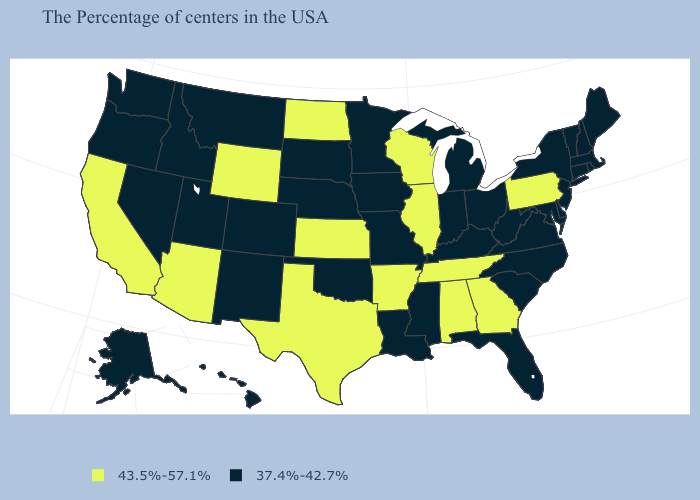Among the states that border West Virginia , does Maryland have the lowest value?
Keep it brief. Yes. Among the states that border Kentucky , does Illinois have the lowest value?
Concise answer only. No. Does the first symbol in the legend represent the smallest category?
Quick response, please. No. Which states have the lowest value in the South?
Keep it brief. Delaware, Maryland, Virginia, North Carolina, South Carolina, West Virginia, Florida, Kentucky, Mississippi, Louisiana, Oklahoma. Which states have the lowest value in the USA?
Be succinct. Maine, Massachusetts, Rhode Island, New Hampshire, Vermont, Connecticut, New York, New Jersey, Delaware, Maryland, Virginia, North Carolina, South Carolina, West Virginia, Ohio, Florida, Michigan, Kentucky, Indiana, Mississippi, Louisiana, Missouri, Minnesota, Iowa, Nebraska, Oklahoma, South Dakota, Colorado, New Mexico, Utah, Montana, Idaho, Nevada, Washington, Oregon, Alaska, Hawaii. Among the states that border Nevada , does Oregon have the highest value?
Short answer required. No. Name the states that have a value in the range 43.5%-57.1%?
Give a very brief answer. Pennsylvania, Georgia, Alabama, Tennessee, Wisconsin, Illinois, Arkansas, Kansas, Texas, North Dakota, Wyoming, Arizona, California. Among the states that border Nevada , does California have the highest value?
Give a very brief answer. Yes. What is the value of Texas?
Give a very brief answer. 43.5%-57.1%. What is the value of Florida?
Give a very brief answer. 37.4%-42.7%. Does the first symbol in the legend represent the smallest category?
Short answer required. No. Name the states that have a value in the range 37.4%-42.7%?
Keep it brief. Maine, Massachusetts, Rhode Island, New Hampshire, Vermont, Connecticut, New York, New Jersey, Delaware, Maryland, Virginia, North Carolina, South Carolina, West Virginia, Ohio, Florida, Michigan, Kentucky, Indiana, Mississippi, Louisiana, Missouri, Minnesota, Iowa, Nebraska, Oklahoma, South Dakota, Colorado, New Mexico, Utah, Montana, Idaho, Nevada, Washington, Oregon, Alaska, Hawaii. Among the states that border Massachusetts , which have the highest value?
Keep it brief. Rhode Island, New Hampshire, Vermont, Connecticut, New York. What is the lowest value in the USA?
Write a very short answer. 37.4%-42.7%. 